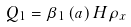Convert formula to latex. <formula><loc_0><loc_0><loc_500><loc_500>Q _ { 1 } = \beta _ { 1 } \left ( a \right ) H \rho _ { x }</formula> 